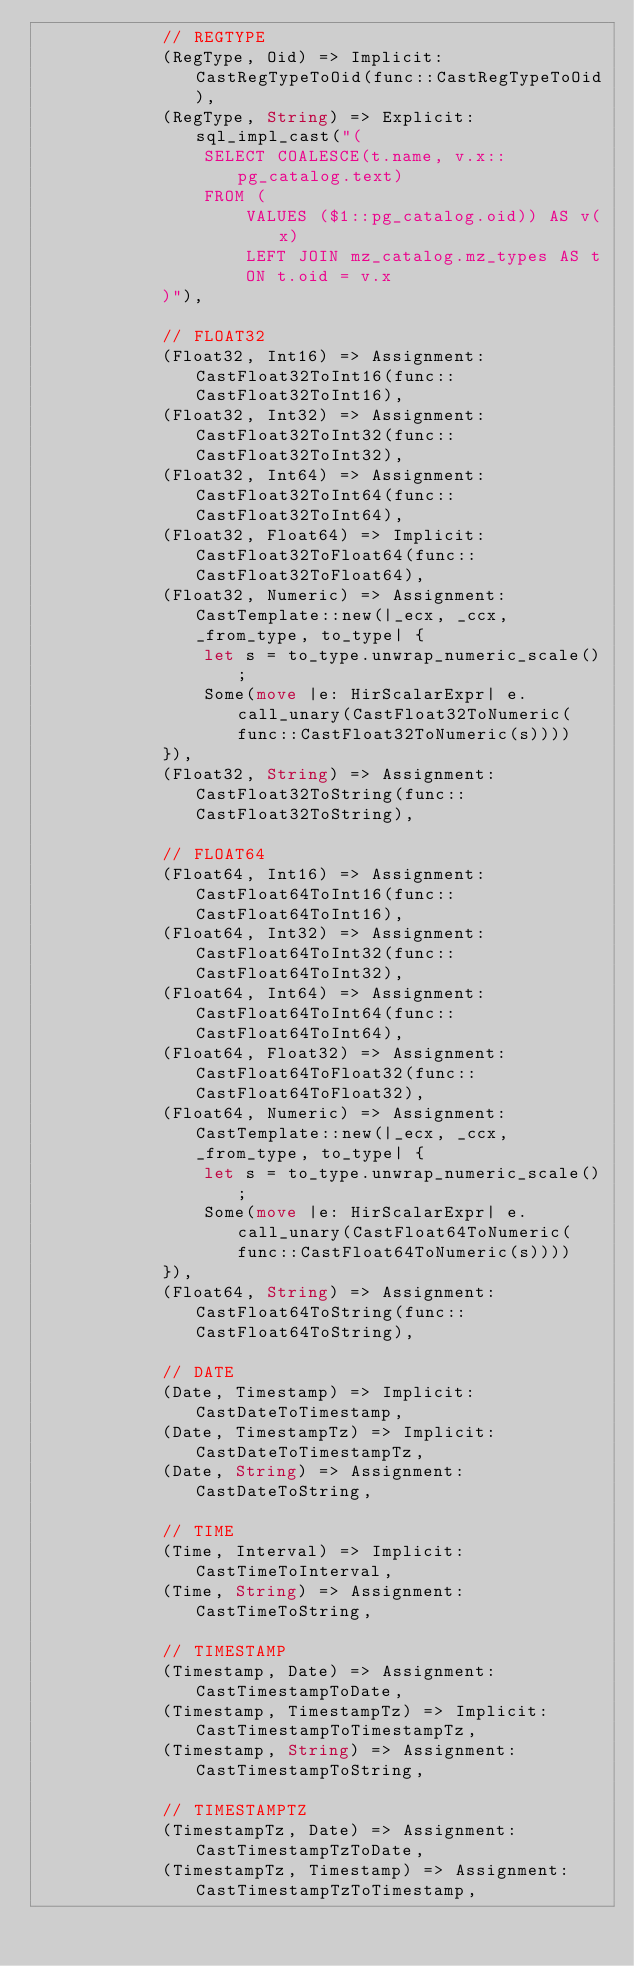<code> <loc_0><loc_0><loc_500><loc_500><_Rust_>            // REGTYPE
            (RegType, Oid) => Implicit: CastRegTypeToOid(func::CastRegTypeToOid),
            (RegType, String) => Explicit: sql_impl_cast("(
                SELECT COALESCE(t.name, v.x::pg_catalog.text)
                FROM (
                    VALUES ($1::pg_catalog.oid)) AS v(x)
                    LEFT JOIN mz_catalog.mz_types AS t
                    ON t.oid = v.x
            )"),

            // FLOAT32
            (Float32, Int16) => Assignment: CastFloat32ToInt16(func::CastFloat32ToInt16),
            (Float32, Int32) => Assignment: CastFloat32ToInt32(func::CastFloat32ToInt32),
            (Float32, Int64) => Assignment: CastFloat32ToInt64(func::CastFloat32ToInt64),
            (Float32, Float64) => Implicit: CastFloat32ToFloat64(func::CastFloat32ToFloat64),
            (Float32, Numeric) => Assignment: CastTemplate::new(|_ecx, _ccx, _from_type, to_type| {
                let s = to_type.unwrap_numeric_scale();
                Some(move |e: HirScalarExpr| e.call_unary(CastFloat32ToNumeric(func::CastFloat32ToNumeric(s))))
            }),
            (Float32, String) => Assignment: CastFloat32ToString(func::CastFloat32ToString),

            // FLOAT64
            (Float64, Int16) => Assignment: CastFloat64ToInt16(func::CastFloat64ToInt16),
            (Float64, Int32) => Assignment: CastFloat64ToInt32(func::CastFloat64ToInt32),
            (Float64, Int64) => Assignment: CastFloat64ToInt64(func::CastFloat64ToInt64),
            (Float64, Float32) => Assignment: CastFloat64ToFloat32(func::CastFloat64ToFloat32),
            (Float64, Numeric) => Assignment: CastTemplate::new(|_ecx, _ccx, _from_type, to_type| {
                let s = to_type.unwrap_numeric_scale();
                Some(move |e: HirScalarExpr| e.call_unary(CastFloat64ToNumeric(func::CastFloat64ToNumeric(s))))
            }),
            (Float64, String) => Assignment: CastFloat64ToString(func::CastFloat64ToString),

            // DATE
            (Date, Timestamp) => Implicit: CastDateToTimestamp,
            (Date, TimestampTz) => Implicit: CastDateToTimestampTz,
            (Date, String) => Assignment: CastDateToString,

            // TIME
            (Time, Interval) => Implicit: CastTimeToInterval,
            (Time, String) => Assignment: CastTimeToString,

            // TIMESTAMP
            (Timestamp, Date) => Assignment: CastTimestampToDate,
            (Timestamp, TimestampTz) => Implicit: CastTimestampToTimestampTz,
            (Timestamp, String) => Assignment: CastTimestampToString,

            // TIMESTAMPTZ
            (TimestampTz, Date) => Assignment: CastTimestampTzToDate,
            (TimestampTz, Timestamp) => Assignment: CastTimestampTzToTimestamp,</code> 